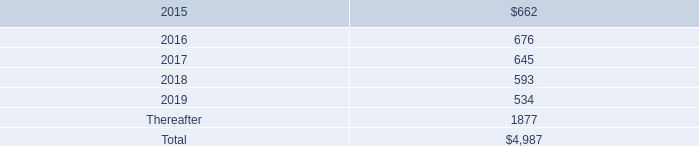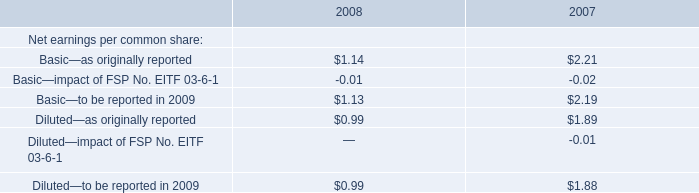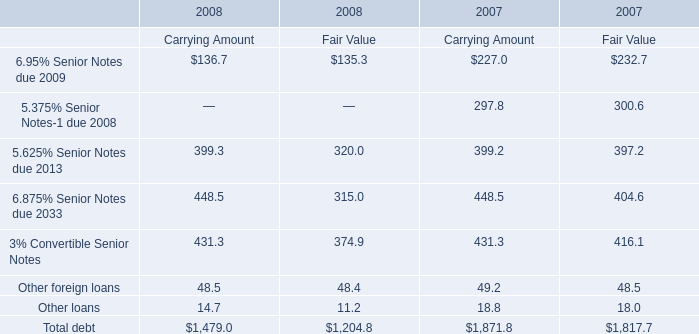Which year is Fair Value for 3% Convertible Senior Notes the lowest? 
Answer: 2008. 